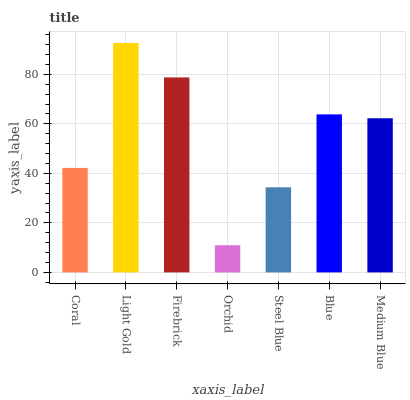Is Orchid the minimum?
Answer yes or no. Yes. Is Light Gold the maximum?
Answer yes or no. Yes. Is Firebrick the minimum?
Answer yes or no. No. Is Firebrick the maximum?
Answer yes or no. No. Is Light Gold greater than Firebrick?
Answer yes or no. Yes. Is Firebrick less than Light Gold?
Answer yes or no. Yes. Is Firebrick greater than Light Gold?
Answer yes or no. No. Is Light Gold less than Firebrick?
Answer yes or no. No. Is Medium Blue the high median?
Answer yes or no. Yes. Is Medium Blue the low median?
Answer yes or no. Yes. Is Blue the high median?
Answer yes or no. No. Is Steel Blue the low median?
Answer yes or no. No. 